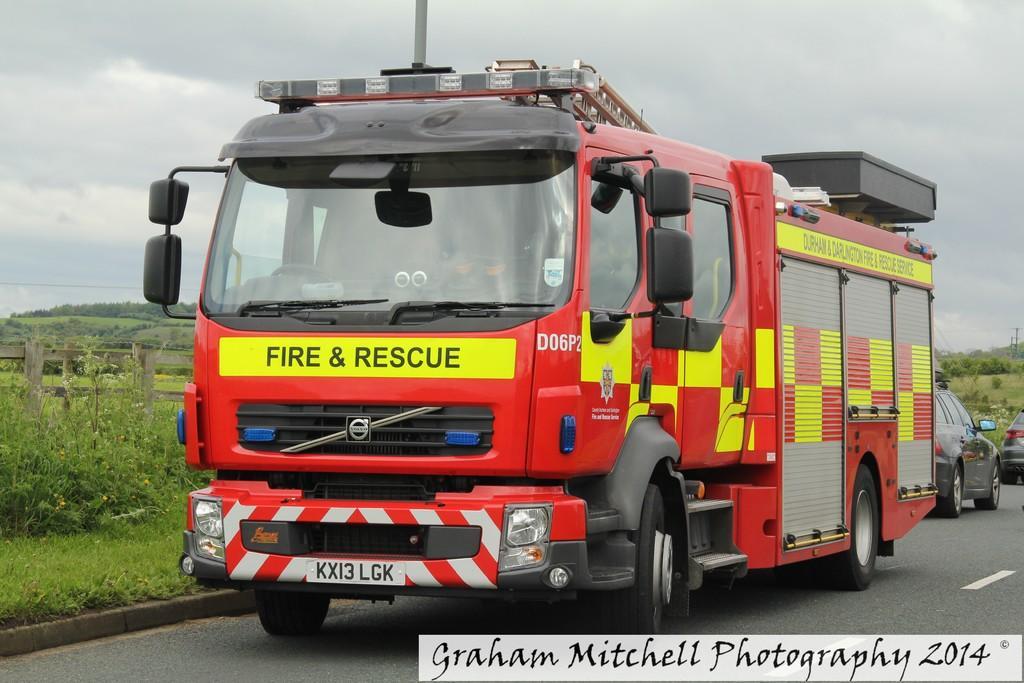Please provide a concise description of this image. In this image I can see a road in the front and on it I can see two cars and a red colour fire truck. In the background I can see grass ground, bushes, clouds and the sky. On the left side of this image I can see wooden railing and on the bottom right side I can see a watermark. 